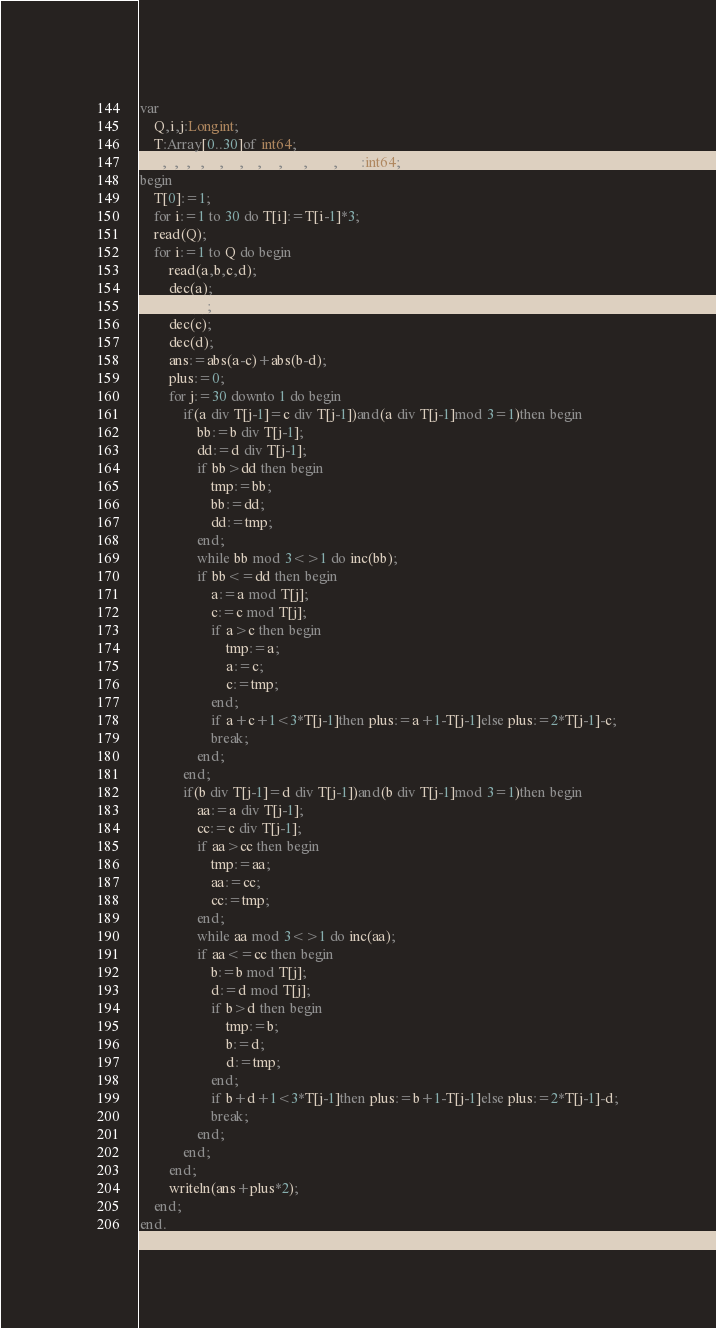<code> <loc_0><loc_0><loc_500><loc_500><_Pascal_>var
	Q,i,j:Longint;
	T:Array[0..30]of int64;
	a,b,c,d,aa,bb,cc,dd,ans,plus,tmp:int64;
begin
	T[0]:=1;
	for i:=1 to 30 do T[i]:=T[i-1]*3;
	read(Q);
	for i:=1 to Q do begin
		read(a,b,c,d);
		dec(a);
		dec(b);
		dec(c);
		dec(d);
		ans:=abs(a-c)+abs(b-d);
		plus:=0;
		for j:=30 downto 1 do begin
			if(a div T[j-1]=c div T[j-1])and(a div T[j-1]mod 3=1)then begin
				bb:=b div T[j-1];
				dd:=d div T[j-1];
				if bb>dd then begin
					tmp:=bb;
					bb:=dd;
					dd:=tmp;
				end;
				while bb mod 3<>1 do inc(bb);
				if bb<=dd then begin
					a:=a mod T[j];
					c:=c mod T[j];
					if a>c then begin
						tmp:=a;
						a:=c;
						c:=tmp;
					end;
					if a+c+1<3*T[j-1]then plus:=a+1-T[j-1]else plus:=2*T[j-1]-c;
					break;
				end;
			end;
			if(b div T[j-1]=d div T[j-1])and(b div T[j-1]mod 3=1)then begin
				aa:=a div T[j-1];
				cc:=c div T[j-1];
				if aa>cc then begin
					tmp:=aa;
					aa:=cc;
					cc:=tmp;
				end;
				while aa mod 3<>1 do inc(aa);
				if aa<=cc then begin
					b:=b mod T[j];
					d:=d mod T[j];
					if b>d then begin
						tmp:=b;
						b:=d;
						d:=tmp;
					end;
					if b+d+1<3*T[j-1]then plus:=b+1-T[j-1]else plus:=2*T[j-1]-d;
					break;
				end;
			end;
		end;
		writeln(ans+plus*2);
	end;
end.
</code> 